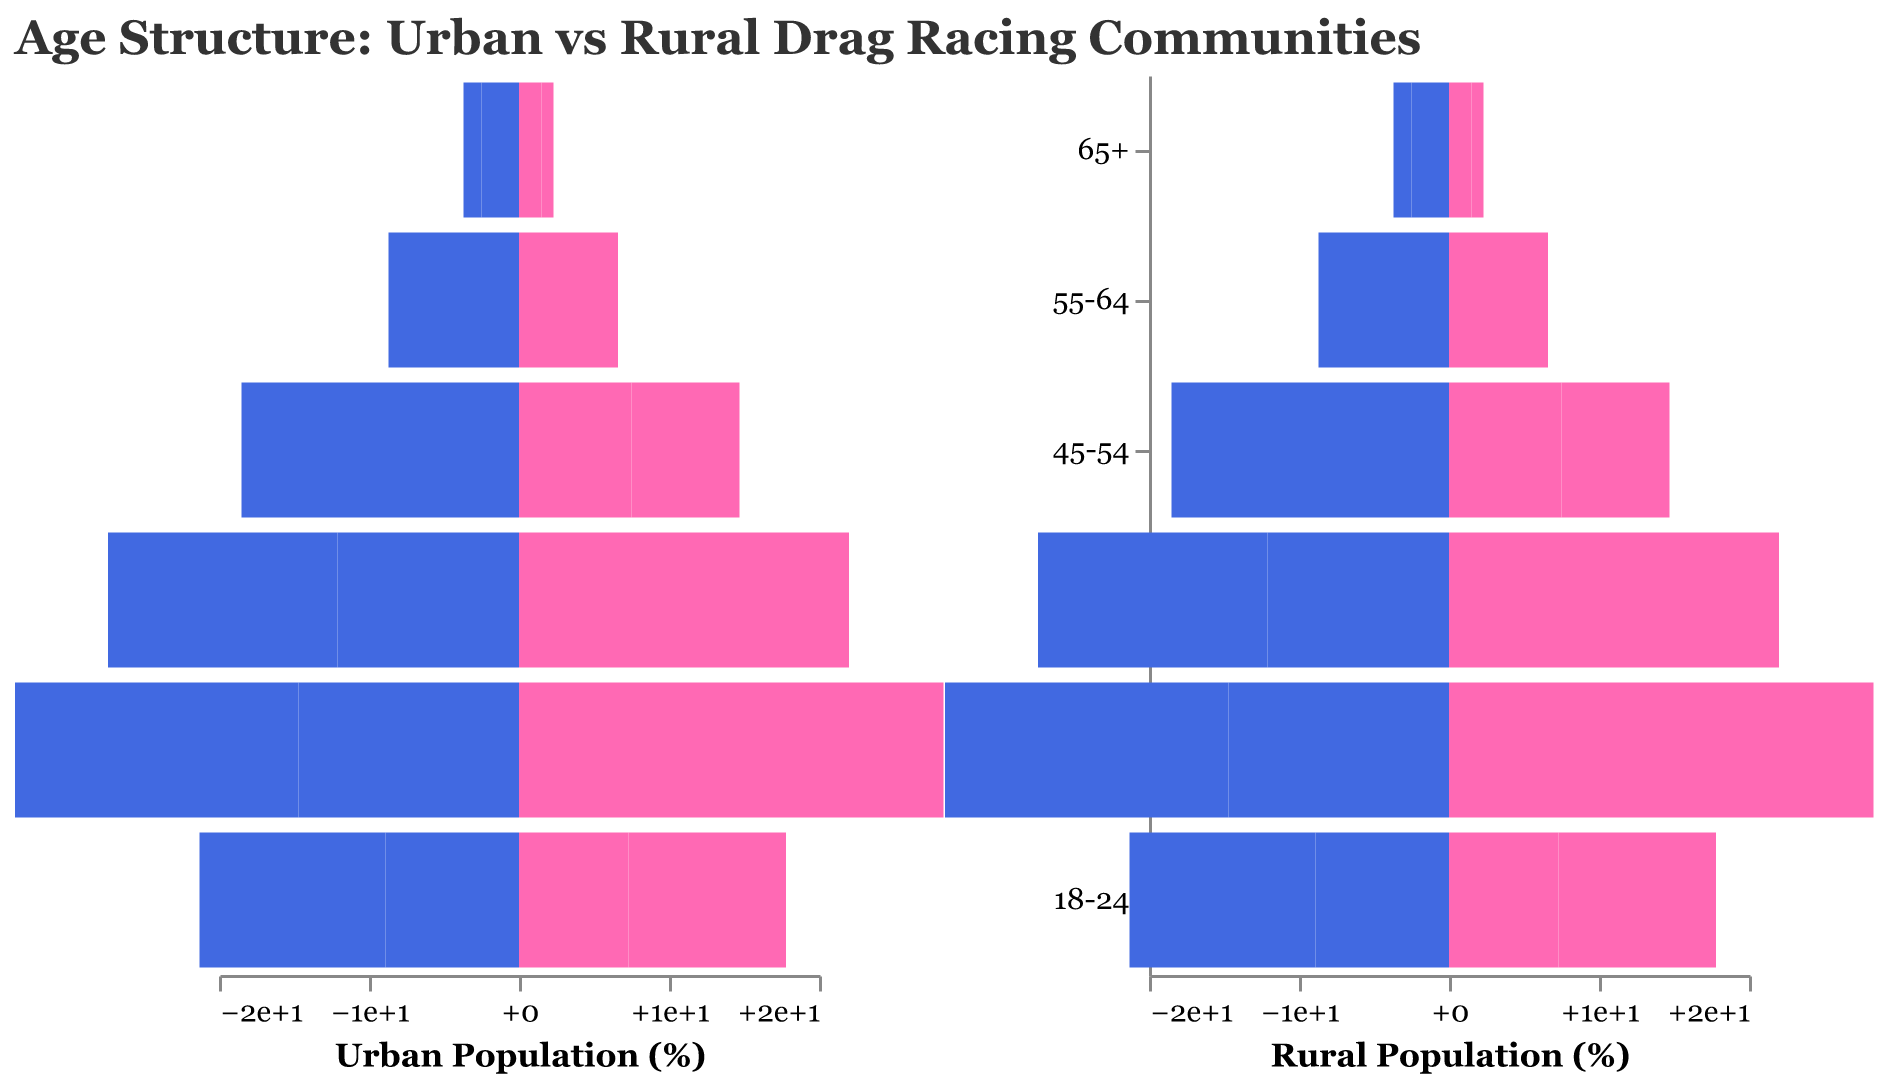What's the title of the figure? The title is displayed at the top of the figure. It reads "Age Structure: Urban vs Rural Drag Racing Communities".
Answer: Age Structure: Urban vs Rural Drag Racing Communities Which age group has the highest percentage of Urban Males? By examining the Urban Males bars on the left side, the "25-34" age group has the longest bar and thus the highest percentage.
Answer: 25-34 What are the colors used to represent Urban Females and Rural Females? Urban Females are represented by a pink color (#FF69B4), and Rural Females are represented by a coral color (#FFA07A).
Answer: Pink and Coral Compare the percentage of Rural Males in the 65+ age group to Urban Males in the same age group. Which is higher? By looking at the "65+" age group bars for both Urban and Rural Males, the Rural Males bar is longer, indicating a higher percentage.
Answer: Rural Males What is the percentage difference between Urban Females and Rural Females in the 18-24 age group? Urban Females in the 18-24 age group have a percentage of 10.5%, and Rural Females have 7.3%. The difference is 10.5 - 7.3 = 3.2%.
Answer: 3.2% In which age group do Rural Females have the lowest percentage? By examining the lengths of the Rural Females bars, the smallest bar is in the "18-24" age group.
Answer: 18-24 Which age group shows a higher percentage of Urban Females compared to Urban Males? In the dataset provided, all age groups have a higher percentage of Urban Males compared to Urban Females, so none fit the criteria.
Answer: None Which community, Urban or Rural, has a higher percentage of participants aged 18-24? Urban Males and Females in the 18-24 age group sum up to 12.4 + 10.5 = 22.9%. Rural Males and Females sum up to 8.9 + 7.3 = 16.2%. Therefore, the Urban community has a higher percentage.
Answer: Urban What is the ratio of Urban Males to Urban Females in the 45-54 age group? Urban Males in the 45-54 age group are 8.7%, and Urban Females are 7.2%. The ratio is 8.7 / 7.2, which simplifies to about 1.21.
Answer: 1.21 